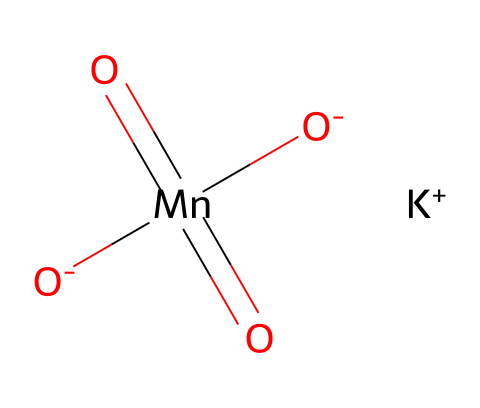What is the formula for potassium permanganate? The SMILES representation identifies the structure as consisting of manganese, oxygen, and potassium. From the breakdown, the formula can be derived as KMnO4.
Answer: KMnO4 How many oxygen atoms are in potassium permanganate? The SMILES representation shows four oxygen atoms connected to manganese, indicating the molecule's composition.
Answer: 4 What is the oxidation state of manganese in potassium permanganate? By examining the structure, manganese is connected to four oxygen atoms (usually with -2 oxidation state), and it has a total charge that leads to it having a +7 oxidation state.
Answer: +7 What is the main use of potassium permanganate? Potassium permanganate is widely recognized for its application in water treatment, particularly for purification and disinfection processes.
Answer: water treatment Why is potassium permanganate considered an oxidizer? The structure revealing manganese in a high oxidation state (+7) signifies its ability to accept electrons from other substances, defining its role as an oxidizing agent.
Answer: oxidizing agent In the structure, what ion accompanies potassium permanganate? The presence of [K+] in the SMILES representation indicates that potassium ions accompany the permanganate ion in the chemical structure.
Answer: potassium ion What is the charge of the permanganate ion in this compound? The structure exhibits two negative charges from the oxygen atoms and the overall combination results in a charge of -1 on the permanganate ion, as reflected in its common formula.
Answer: -1 